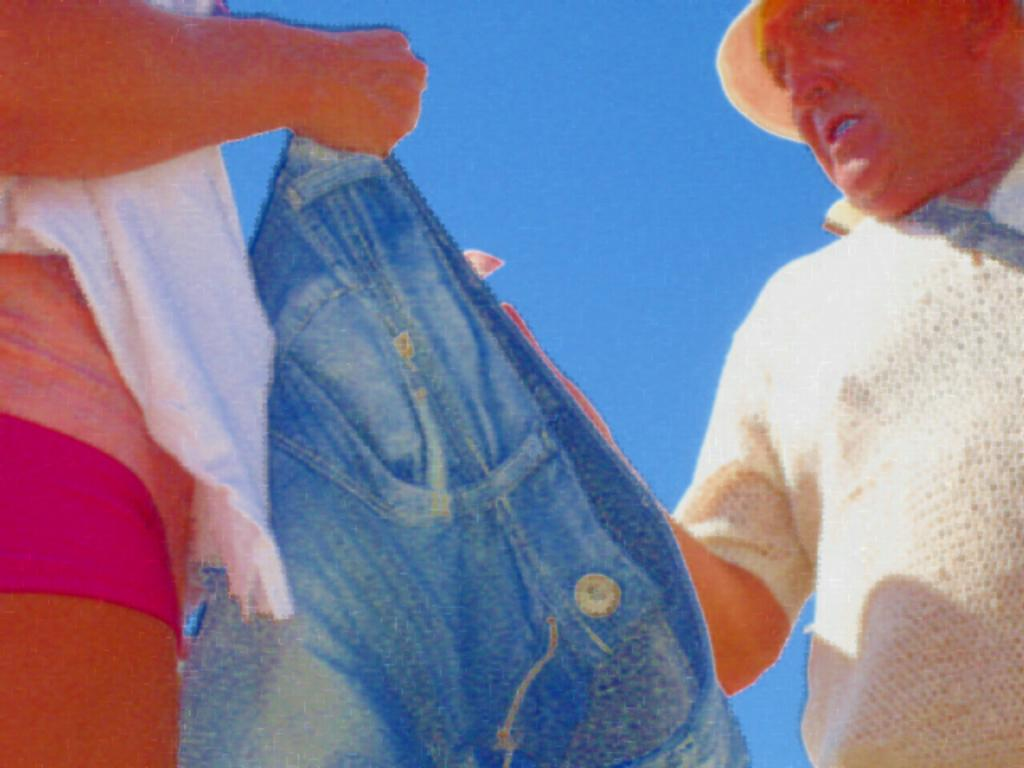How many people are present in the image? There are two people standing in the image. What is one of the people holding? One person is holding a pair of jeans. What can be seen in the background of the image? The sky is visible behind the people. How many kittens are sitting on the loaf of bread in the image? There are no kittens or loaf of bread present in the image. 